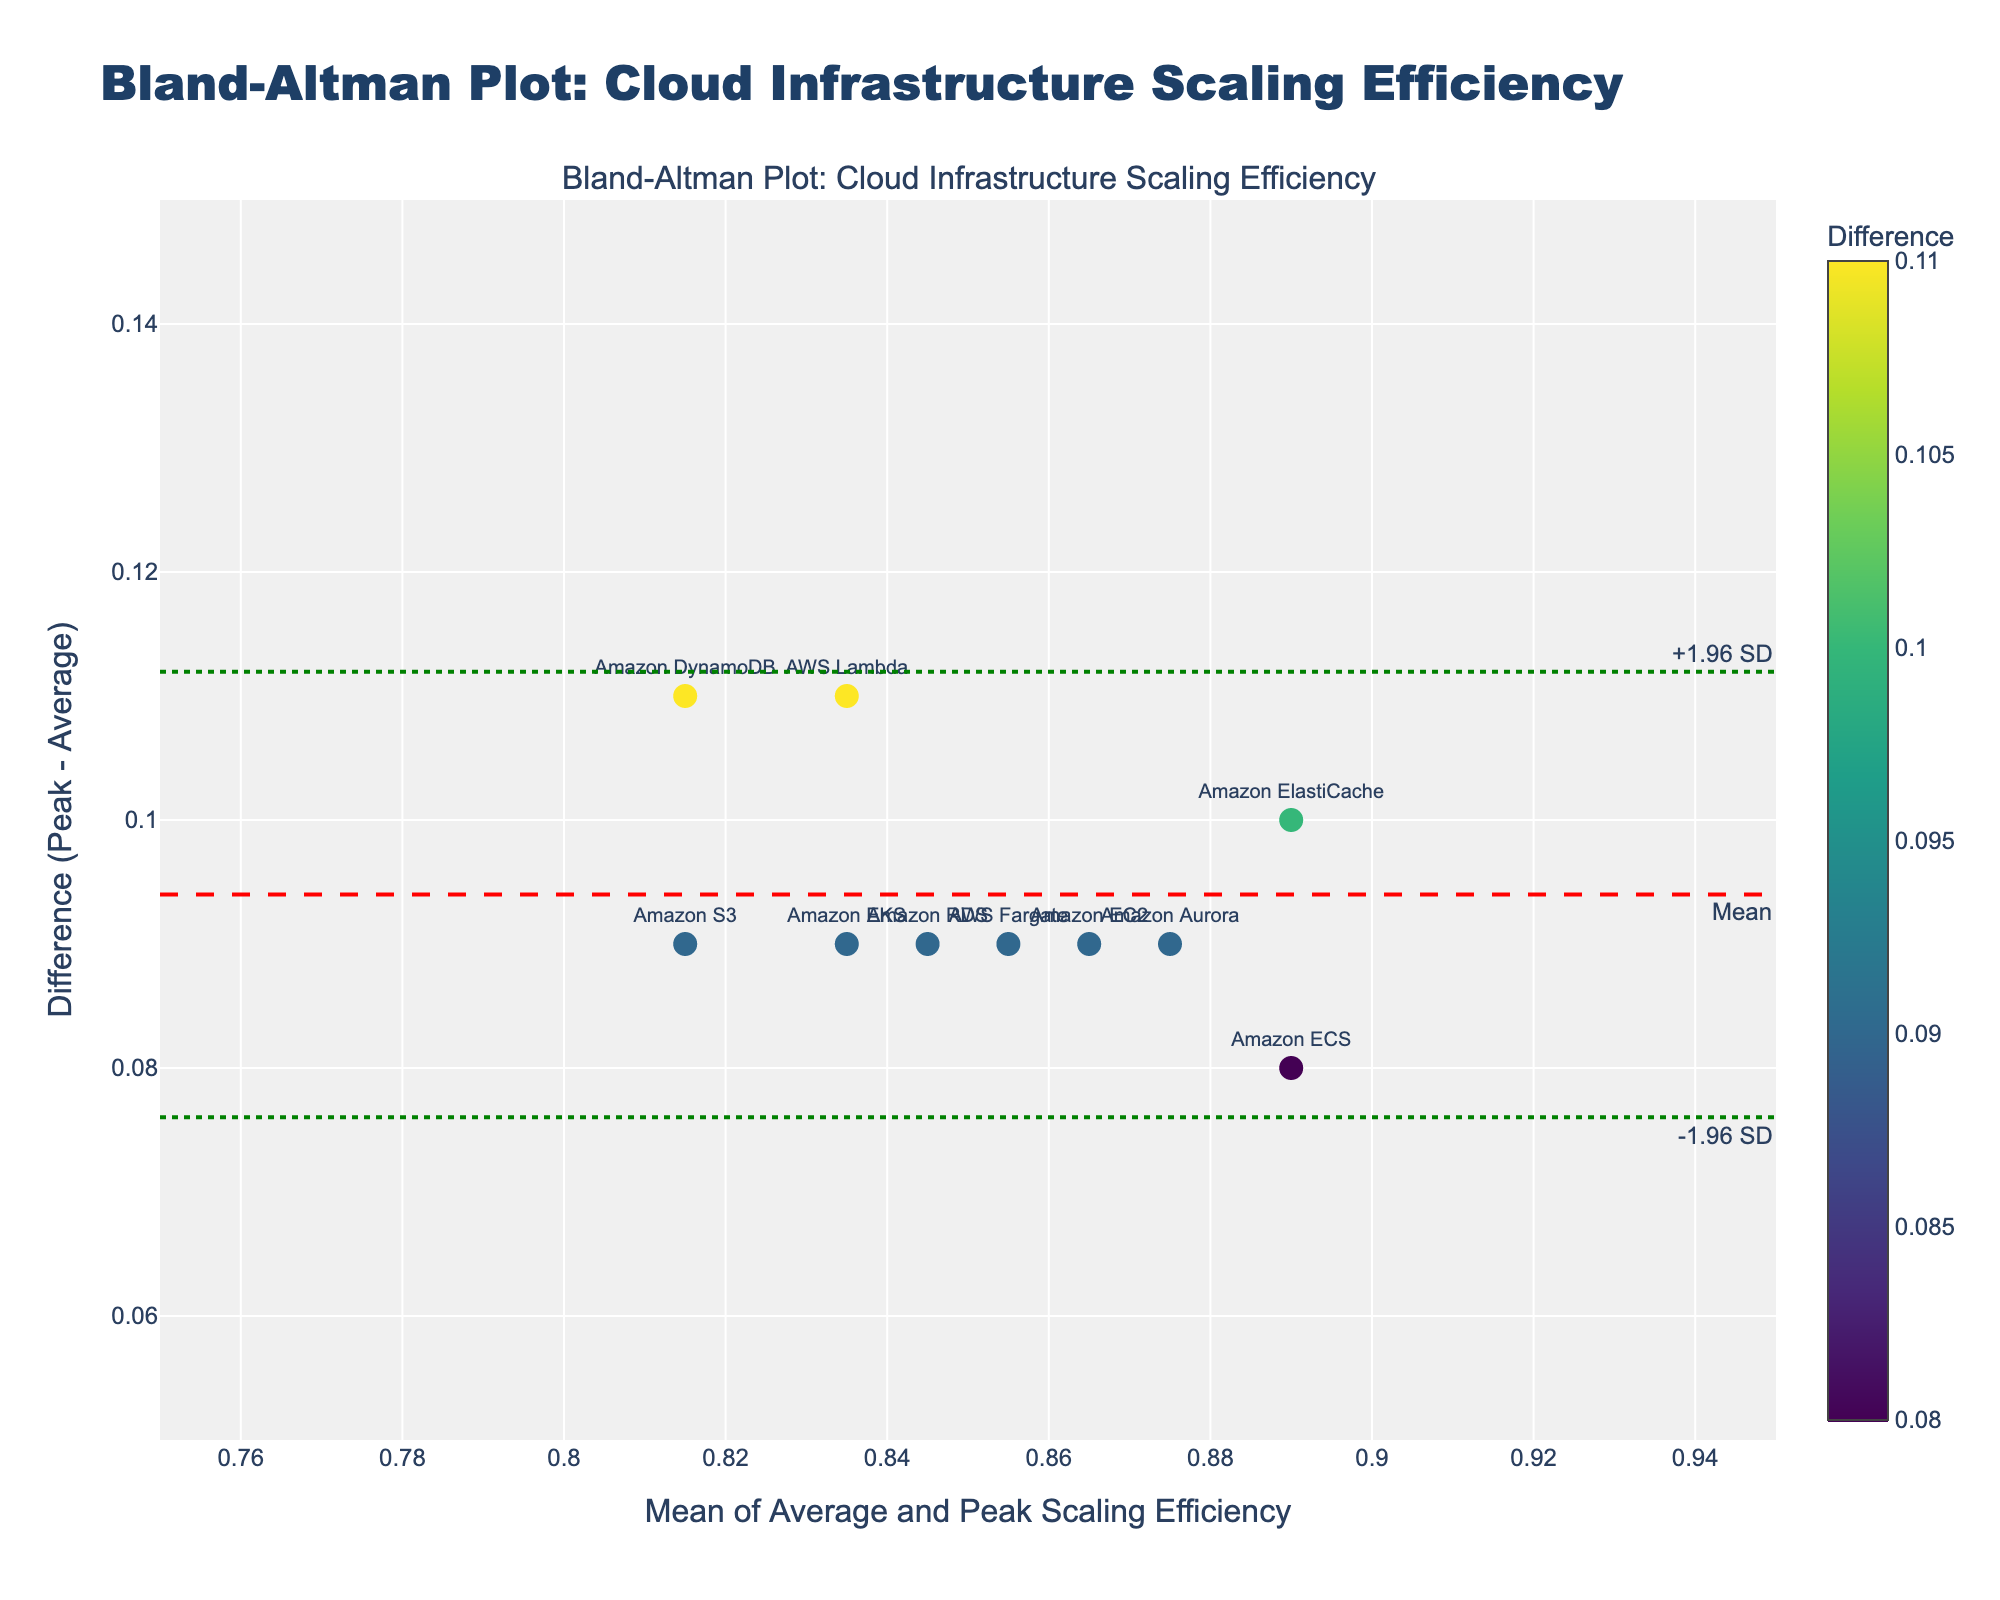How many services are represented in the Bland–Altman plot? Count the number of distinct data points or labels on the plot representing different services.
Answer: 10 What is the title of the Bland–Altman plot? Refer to the top of the plot where the title is usually placed.
Answer: Bland-Altman Plot: Cloud Infrastructure Scaling Efficiency What does the y-axis represent in this Bland–Altman plot? Look at the y-axis label to identify what it represents.
Answer: Difference (Peak - Average) What color scale is used for the markers in the plot? Observe the markers' colors and the associated color scale legend.
Answer: Viridis What is the range of the x-axis in this plot? Check the numeric values at the beginning and end of the x-axis.
Answer: 0.75 to 0.95 What is the mean difference value represented by the dashed red line? Identify the value indicated by the dashed red line marked as "Mean".
Answer: 0.12 What is the range for the limits of agreement? Look at the values indicated by the green dotted lines and labeled as "-1.96 SD" and "+1.96 SD".
Answer: 0.078 to 0.162 What does a difference value of 0.10 on the y-axis signify in this context? A difference value of 0.10 means that the peak scaling efficiency is 0.10 higher than the average scaling efficiency for the specific service.
Answer: Peak scaling efficiency is 0.10 higher than average Which service has the largest difference between peak and average scaling efficiency? Identify the highest data point on the y-axis and check the associated label.
Answer: Amazon ElastiCache Which service has the smallest difference between peak and average scaling efficiency? Identify the lowest data point on the y-axis and check the associated label.
Answer: Amazon S3 